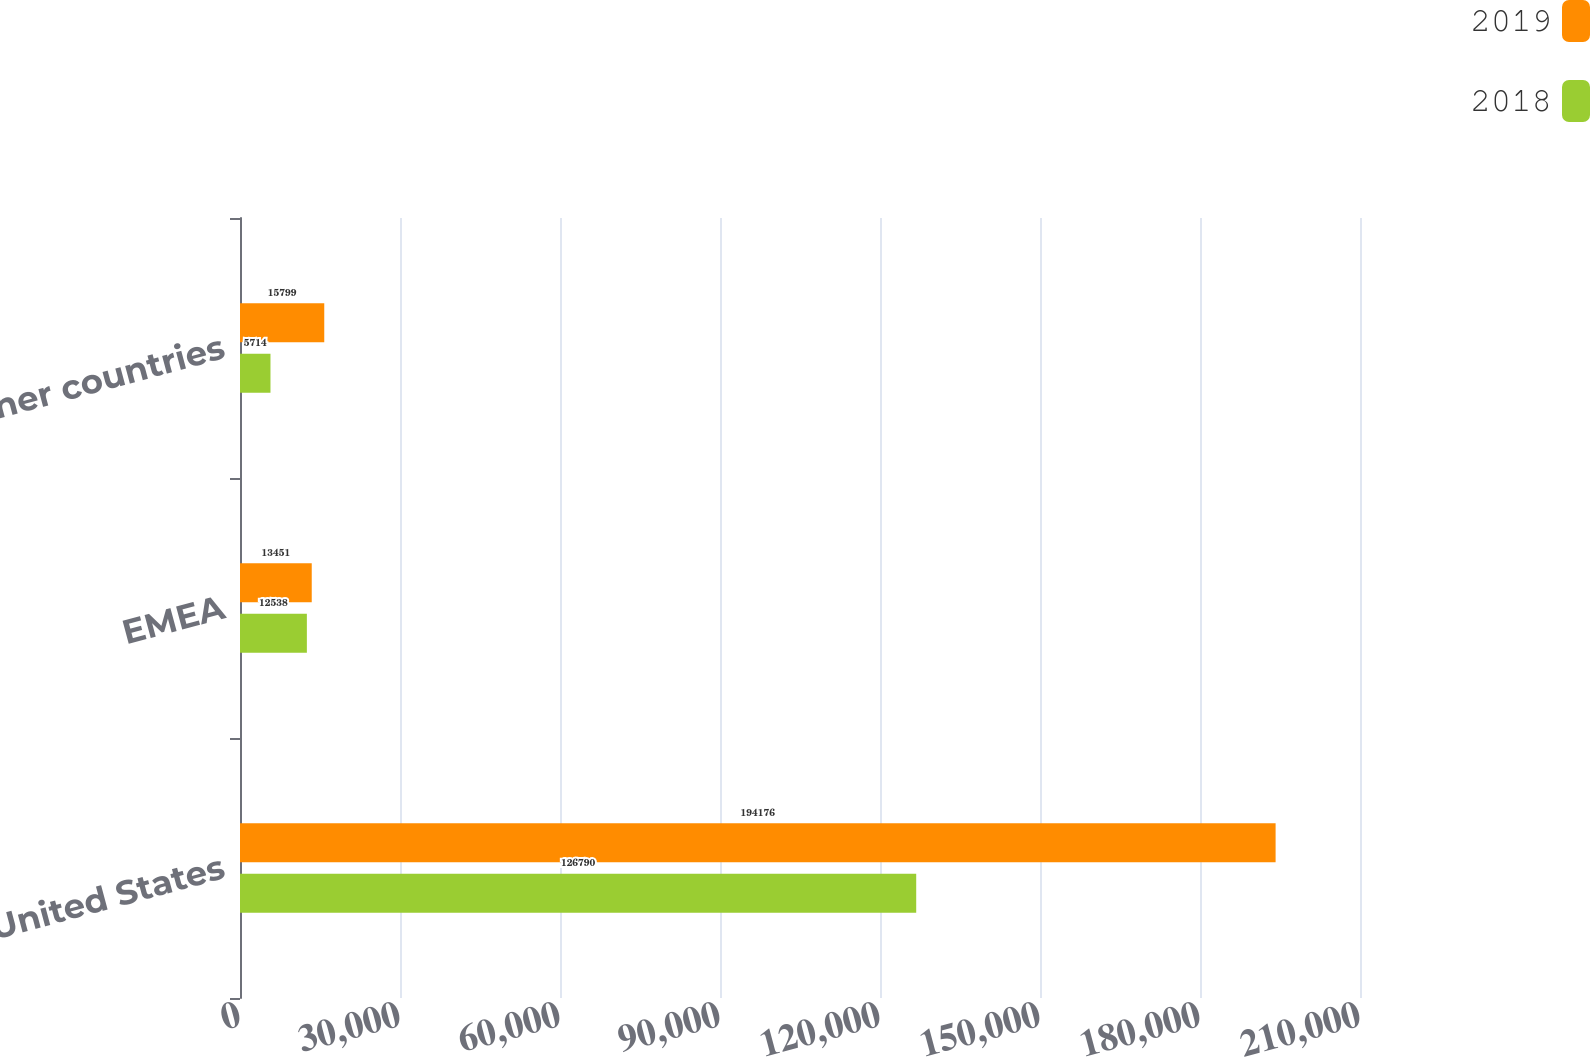Convert chart. <chart><loc_0><loc_0><loc_500><loc_500><stacked_bar_chart><ecel><fcel>United States<fcel>EMEA<fcel>Other countries<nl><fcel>2019<fcel>194176<fcel>13451<fcel>15799<nl><fcel>2018<fcel>126790<fcel>12538<fcel>5714<nl></chart> 